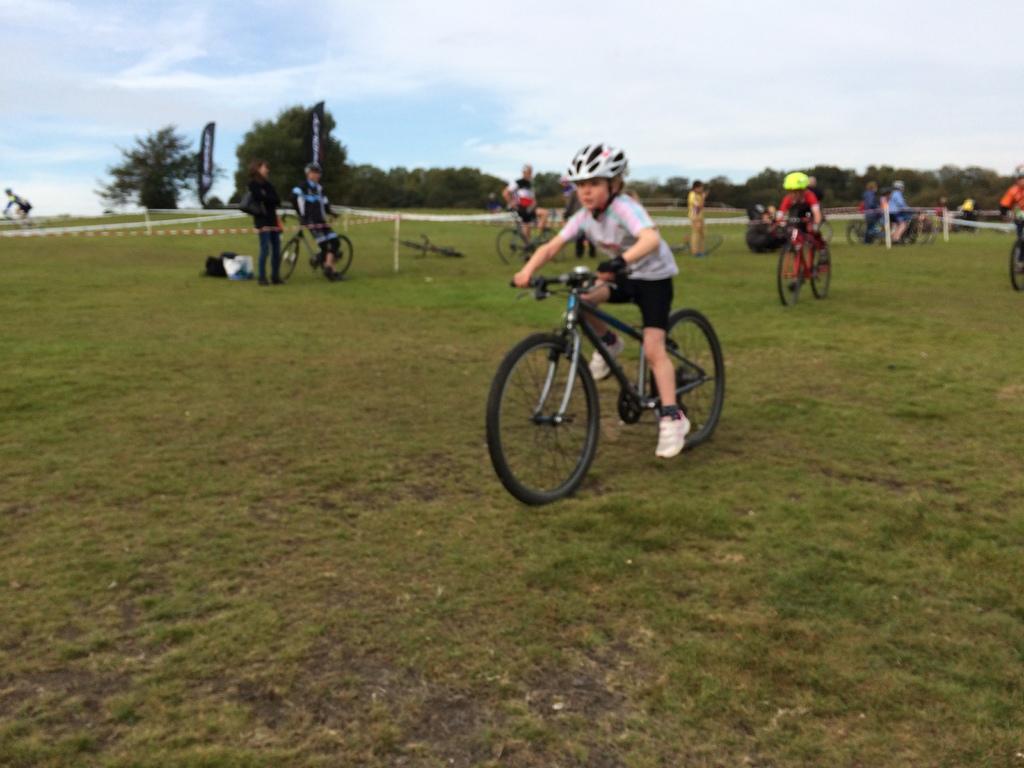Please provide a concise description of this image. Land is covered with grass. Children are riding bicycles. Background we can see bicycles. people, trees, hoarding and cloudy sky. 